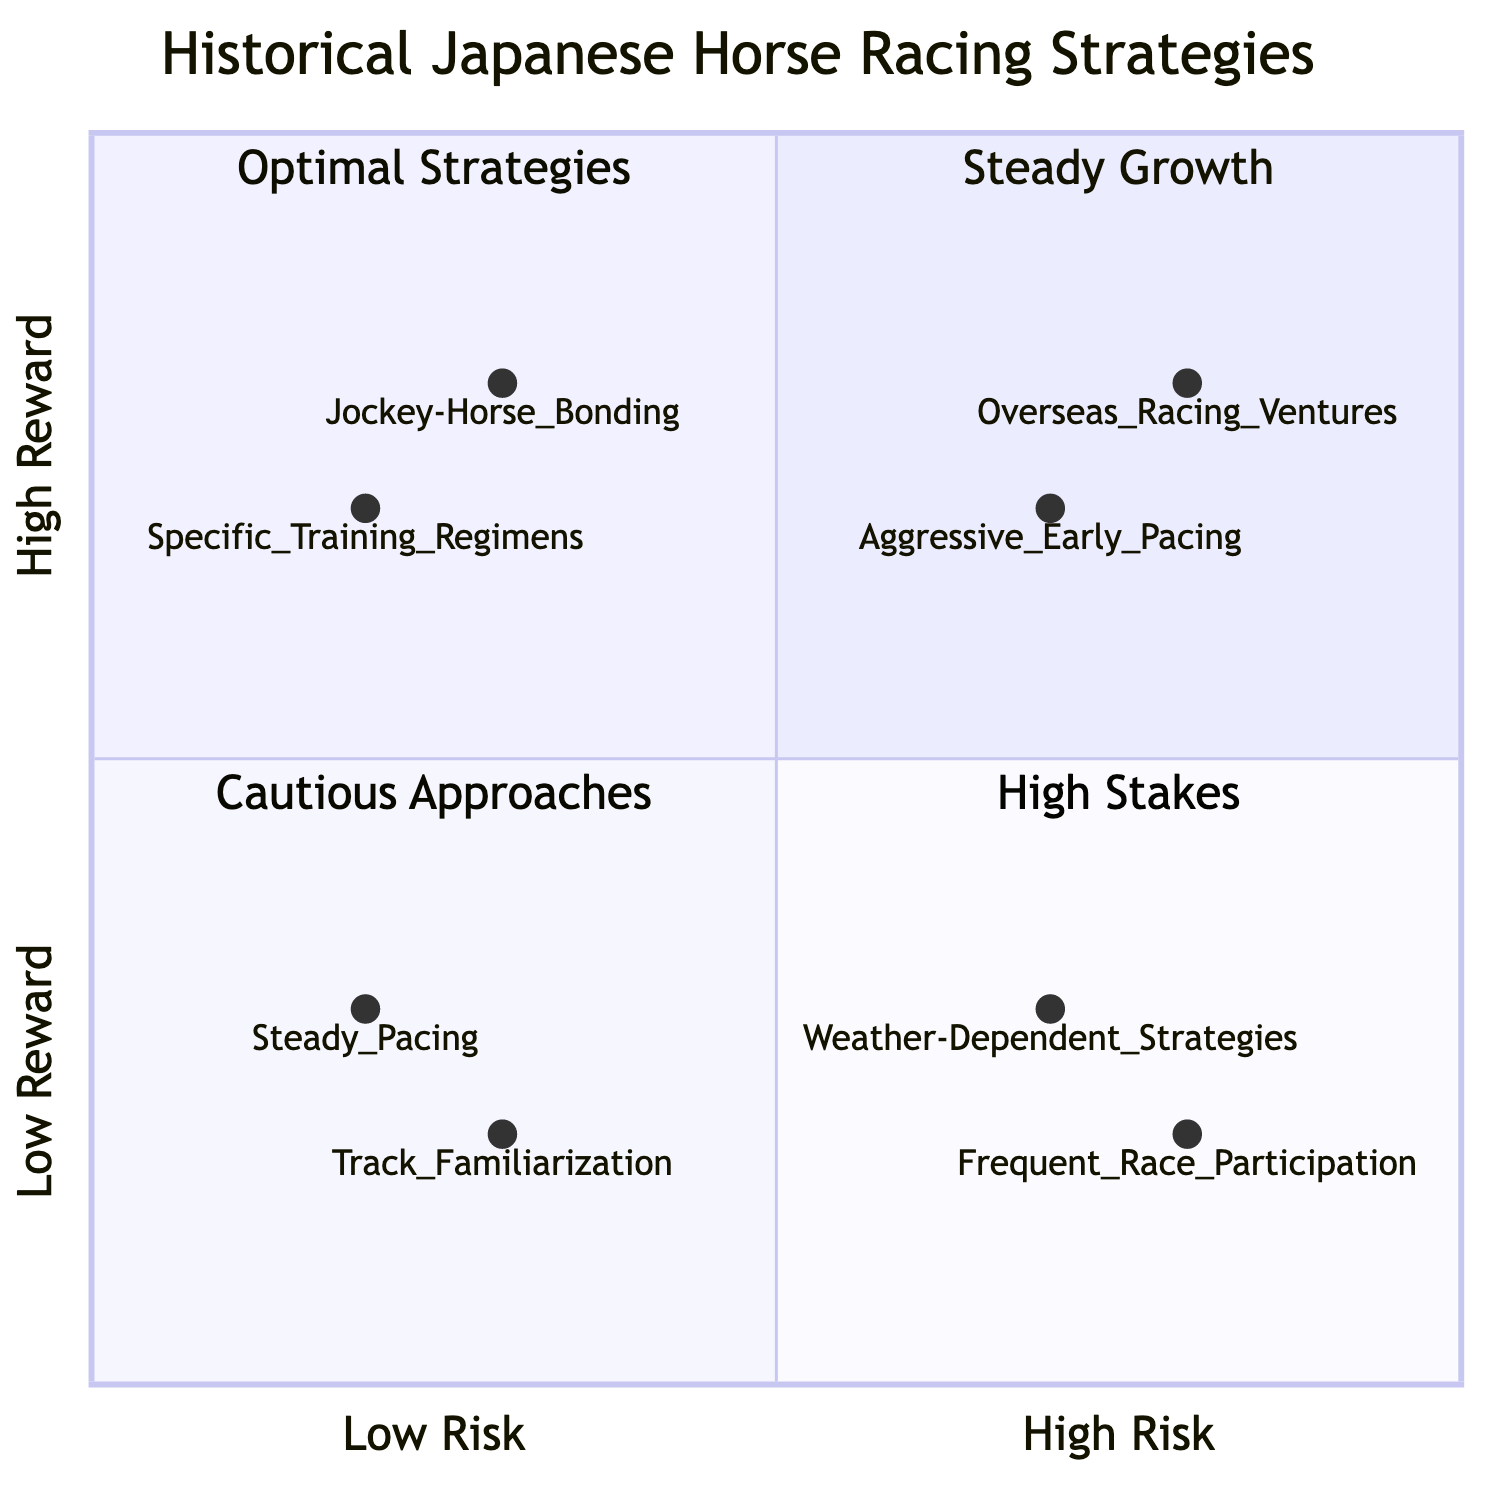What is located in the "Low Risk - Low Reward" quadrant? The "Low Risk - Low Reward" quadrant contains "Steady Pacing" and "Track Familiarization". By examining the diagram, we find that these strategies are placed in this quadrant due to their characteristics of low risk and low reward.
Answer: Steady Pacing, Track Familiarization Which strategy has the highest risk in the chart? The strategy that has the highest risk in the chart is "Overseas Racing Ventures". This can be determined by looking at the x-axis for high-risk strategies, and finding "Overseas Racing Ventures" within the "High Risk - High Reward" quadrant.
Answer: Overseas Racing Ventures How many strategies are in the "High Risk - Low Reward" quadrant? The "High Risk - Low Reward" quadrant contains two strategies: "Weather-Dependent Strategies" and "Frequent Race Participation". Counting these from the diagram confirms that there are two strategies in this category.
Answer: 2 Which strategy focuses on strong jockey-horse relationships? The strategy that focuses on strong jockey-horse relationships is "Jockey-Horse Bonding". This is evident from its name and description, which emphasize the importance of bonding between the jockey and the horse located in the "Low Risk - High Reward" quadrant.
Answer: Jockey-Horse Bonding Is "Aggressive Early Pacing" classified as a high reward strategy? Yes, "Aggressive Early Pacing" is classified as a high reward strategy. It is positioned in the "High Risk - High Reward" quadrant and the term 'aggressive' implies an intention for higher returns often seen in these strategies.
Answer: Yes What is the y-axis descriptor of the quadrant containing "Specific Training Regimens"? The y-axis descriptor of the quadrant containing "Specific Training Regimens" is "High Reward". Since "Specific Training Regimens" falls into the "Low Risk - High Reward" category, we can conclude its respective y-axis label is associated with higher rewards.
Answer: High Reward Which strategy involves a consistent race pace? The strategy that involves a consistent race pace is "Steady Pacing". It is described in the diagram specifically as such and positioned in the "Low Risk - Low Reward" quadrant reflecting its slower, low-consequential approach.
Answer: Steady Pacing Is there a strategy that has both high risk and low reward? No, there isn't a strategy that has both high risk and low reward. By examining the quadrants, we see that high-risk strategies tend to also have high potential rewards, as evident in the "High Risk - High Reward" quadrant.
Answer: No 